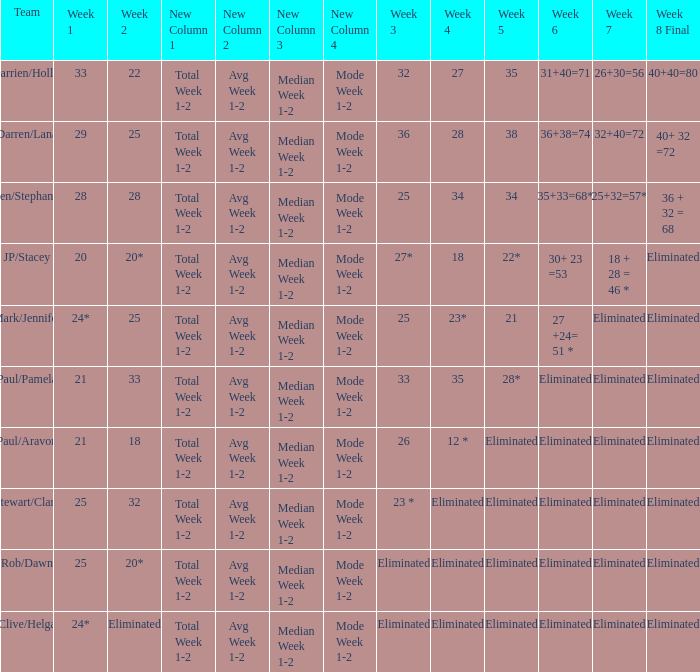Name the team for week 1 of 33 Darrien/Hollie. 